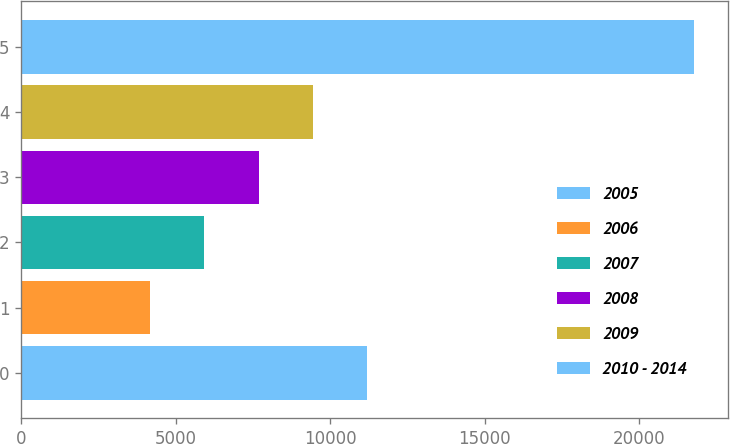Convert chart. <chart><loc_0><loc_0><loc_500><loc_500><bar_chart><fcel>2005<fcel>2006<fcel>2007<fcel>2008<fcel>2009<fcel>2010 - 2014<nl><fcel>11206.8<fcel>4162<fcel>5923.2<fcel>7684.4<fcel>9445.6<fcel>21774<nl></chart> 